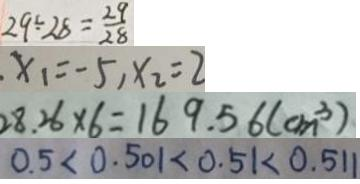<formula> <loc_0><loc_0><loc_500><loc_500>2 9 \div 2 8 = \frac { 2 9 } { 2 8 } 
 x _ { 1 } = - 5 , x _ { 2 } = 2 
 2 8 . 2 6 \times 6 = 1 6 9 . 5 6 ( c m ^ { 3 } ) 
 0 . 5 < 0 . 5 0 1 < 0 . 5 1 < 0 . 5 1 1</formula> 